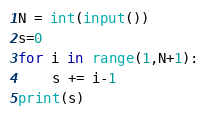Convert code to text. <code><loc_0><loc_0><loc_500><loc_500><_Python_>N = int(input())
s=0
for i in range(1,N+1):
    s += i-1
print(s)</code> 